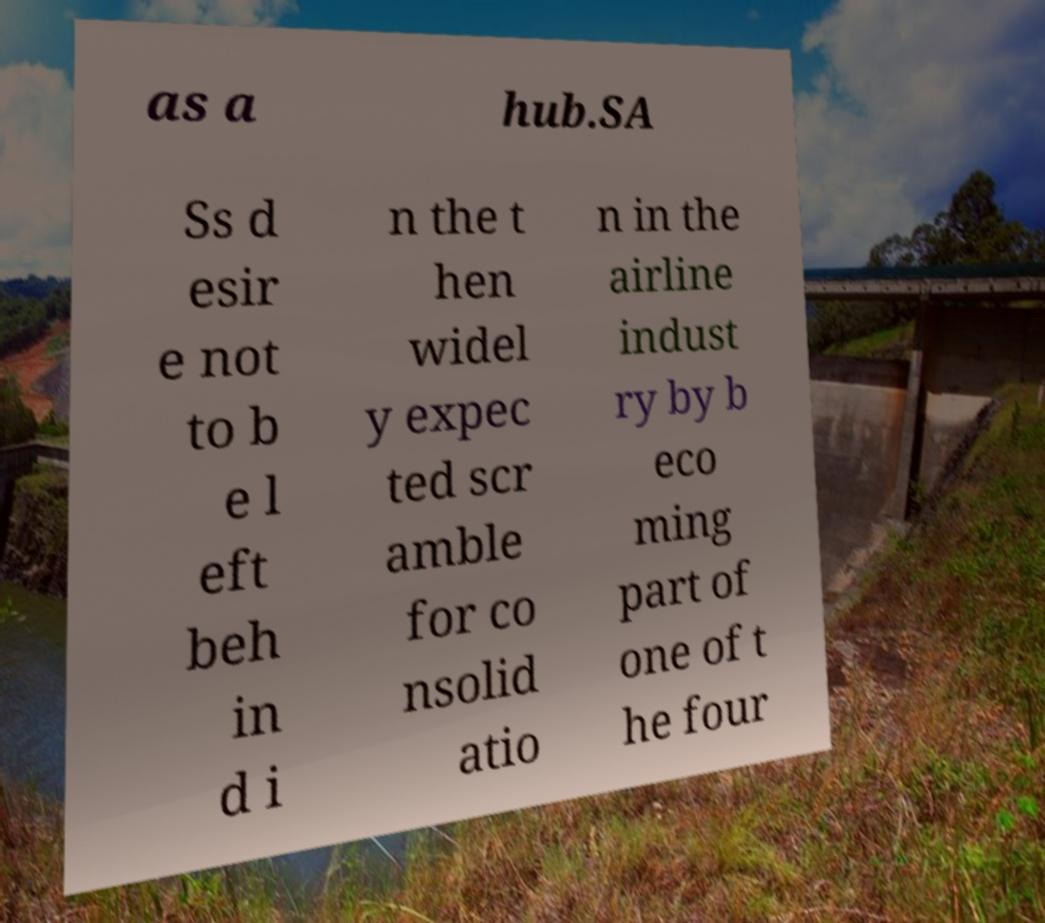Please read and relay the text visible in this image. What does it say? as a hub.SA Ss d esir e not to b e l eft beh in d i n the t hen widel y expec ted scr amble for co nsolid atio n in the airline indust ry by b eco ming part of one of t he four 